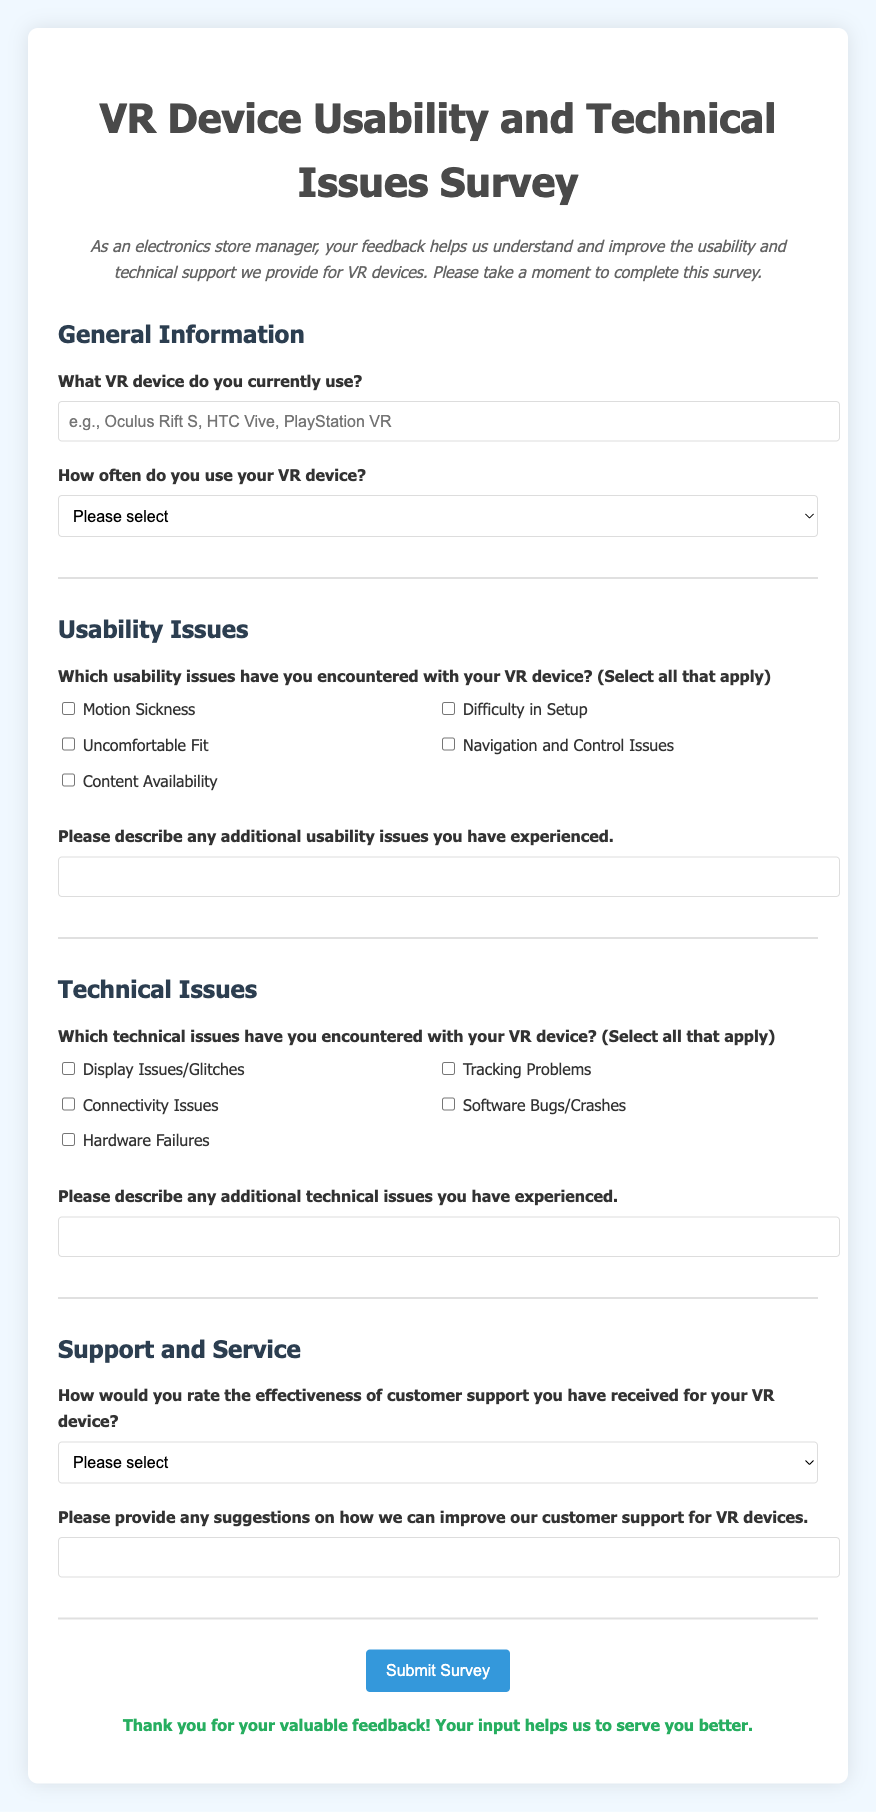What is the title of the survey? The title of the survey is prominently displayed at the top of the document, which is "VR Device Usability and Technical Issues Survey."
Answer: VR Device Usability and Technical Issues Survey What type of feedback does the survey seek? The survey is designed to collect feedback on usability and technical support for VR devices, as stated in the description.
Answer: Usability and technical support How often does the survey ask users to report their VR usage frequency? The survey includes a question that asks how often users utilize their VR device, offering various options.
Answer: Frequency of usage What are some usability issues listed in the survey? The survey provides a checklist of usability issues, including "Motion Sickness," "Difficulty in Setup," and others.
Answer: Motion Sickness, Difficulty in Setup How would users rate customer support on the survey? Users are asked to rate the effectiveness of customer support using a standard rating scale provided in the survey.
Answer: Rating scale What additional feedback does the survey request regarding support? The survey includes a question asking for suggestions on how to improve customer support for VR devices.
Answer: Suggestions for improvement What is the color of the background used in the survey? The background color of the document is specified in the style section as light blue (#f0f8ff).
Answer: Light blue Is there a section dedicated to technical issues in the survey? Yes, the survey includes a dedicated section titled "Technical Issues," to address various technical problems faced by users.
Answer: Yes How can users submit their survey responses? Users can submit their responses by clicking the "Submit Survey" button at the end of the form.
Answer: Submit Survey button 